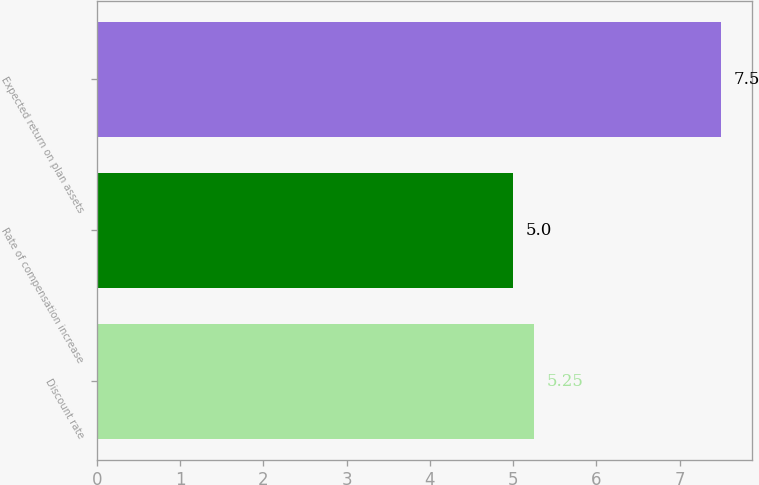Convert chart to OTSL. <chart><loc_0><loc_0><loc_500><loc_500><bar_chart><fcel>Discount rate<fcel>Rate of compensation increase<fcel>Expected return on plan assets<nl><fcel>5.25<fcel>5<fcel>7.5<nl></chart> 